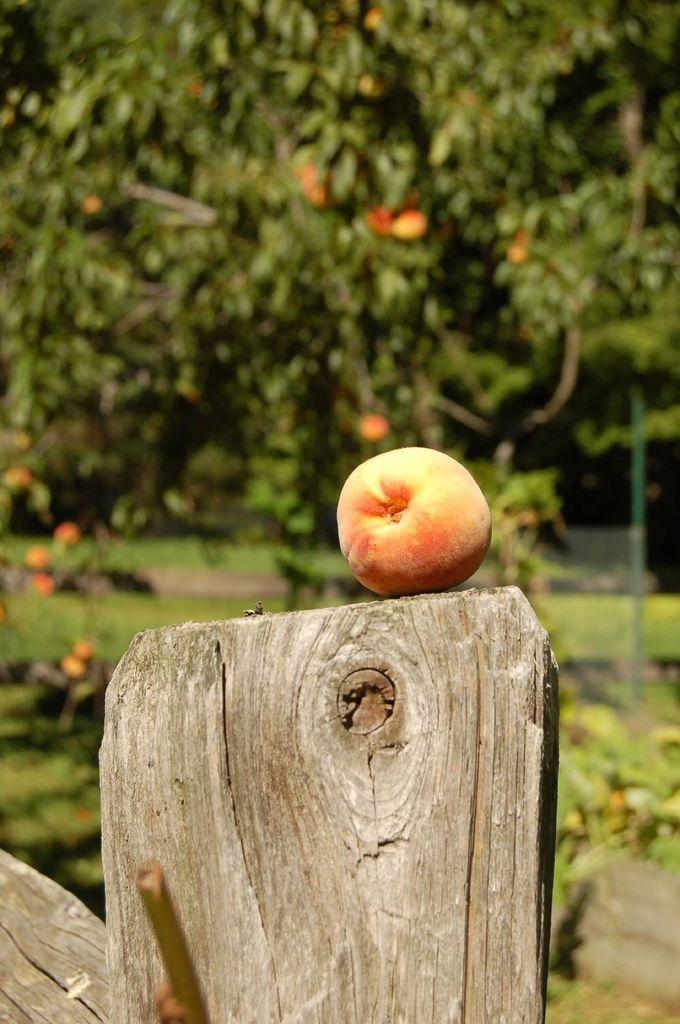What type of vegetation can be seen in the image? There are trees in the image. What fruit is present in the image? There is a peach in the image. On what surface is the peach placed? The peach is on a wooden block. What is the temperature of the peach in the image? The temperature of the peach cannot be determined from the image alone. --- 